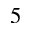<formula> <loc_0><loc_0><loc_500><loc_500>5</formula> 